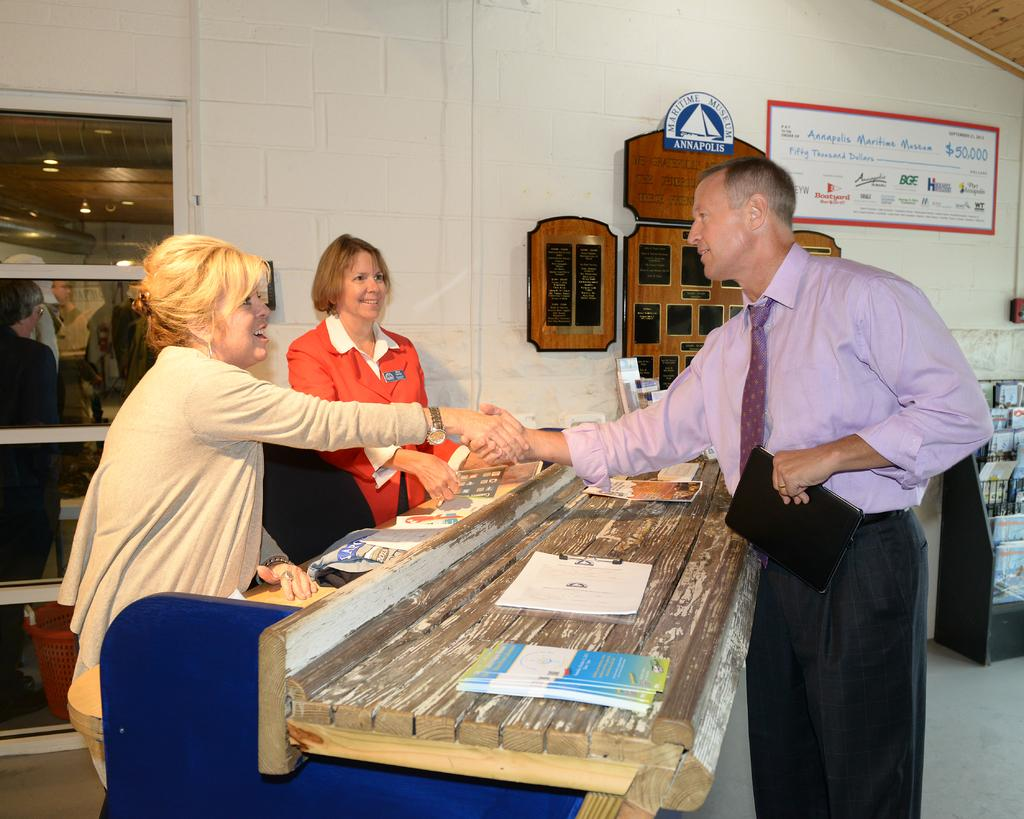What are the people in the image doing? The persons standing on the floor are likely engaged in some activity or conversation. What objects can be seen on the bench? There are books and papers on the bench. How are the books organized in the image? The books are arranged in a rack. What type of signage is present in the image? There is an advertisement board in the image. What decorative items are present on the wall? Wall hangings are present on the wall. How does the person adjust their finger in the image? There is no specific action involving a finger mentioned or visible in the image. 